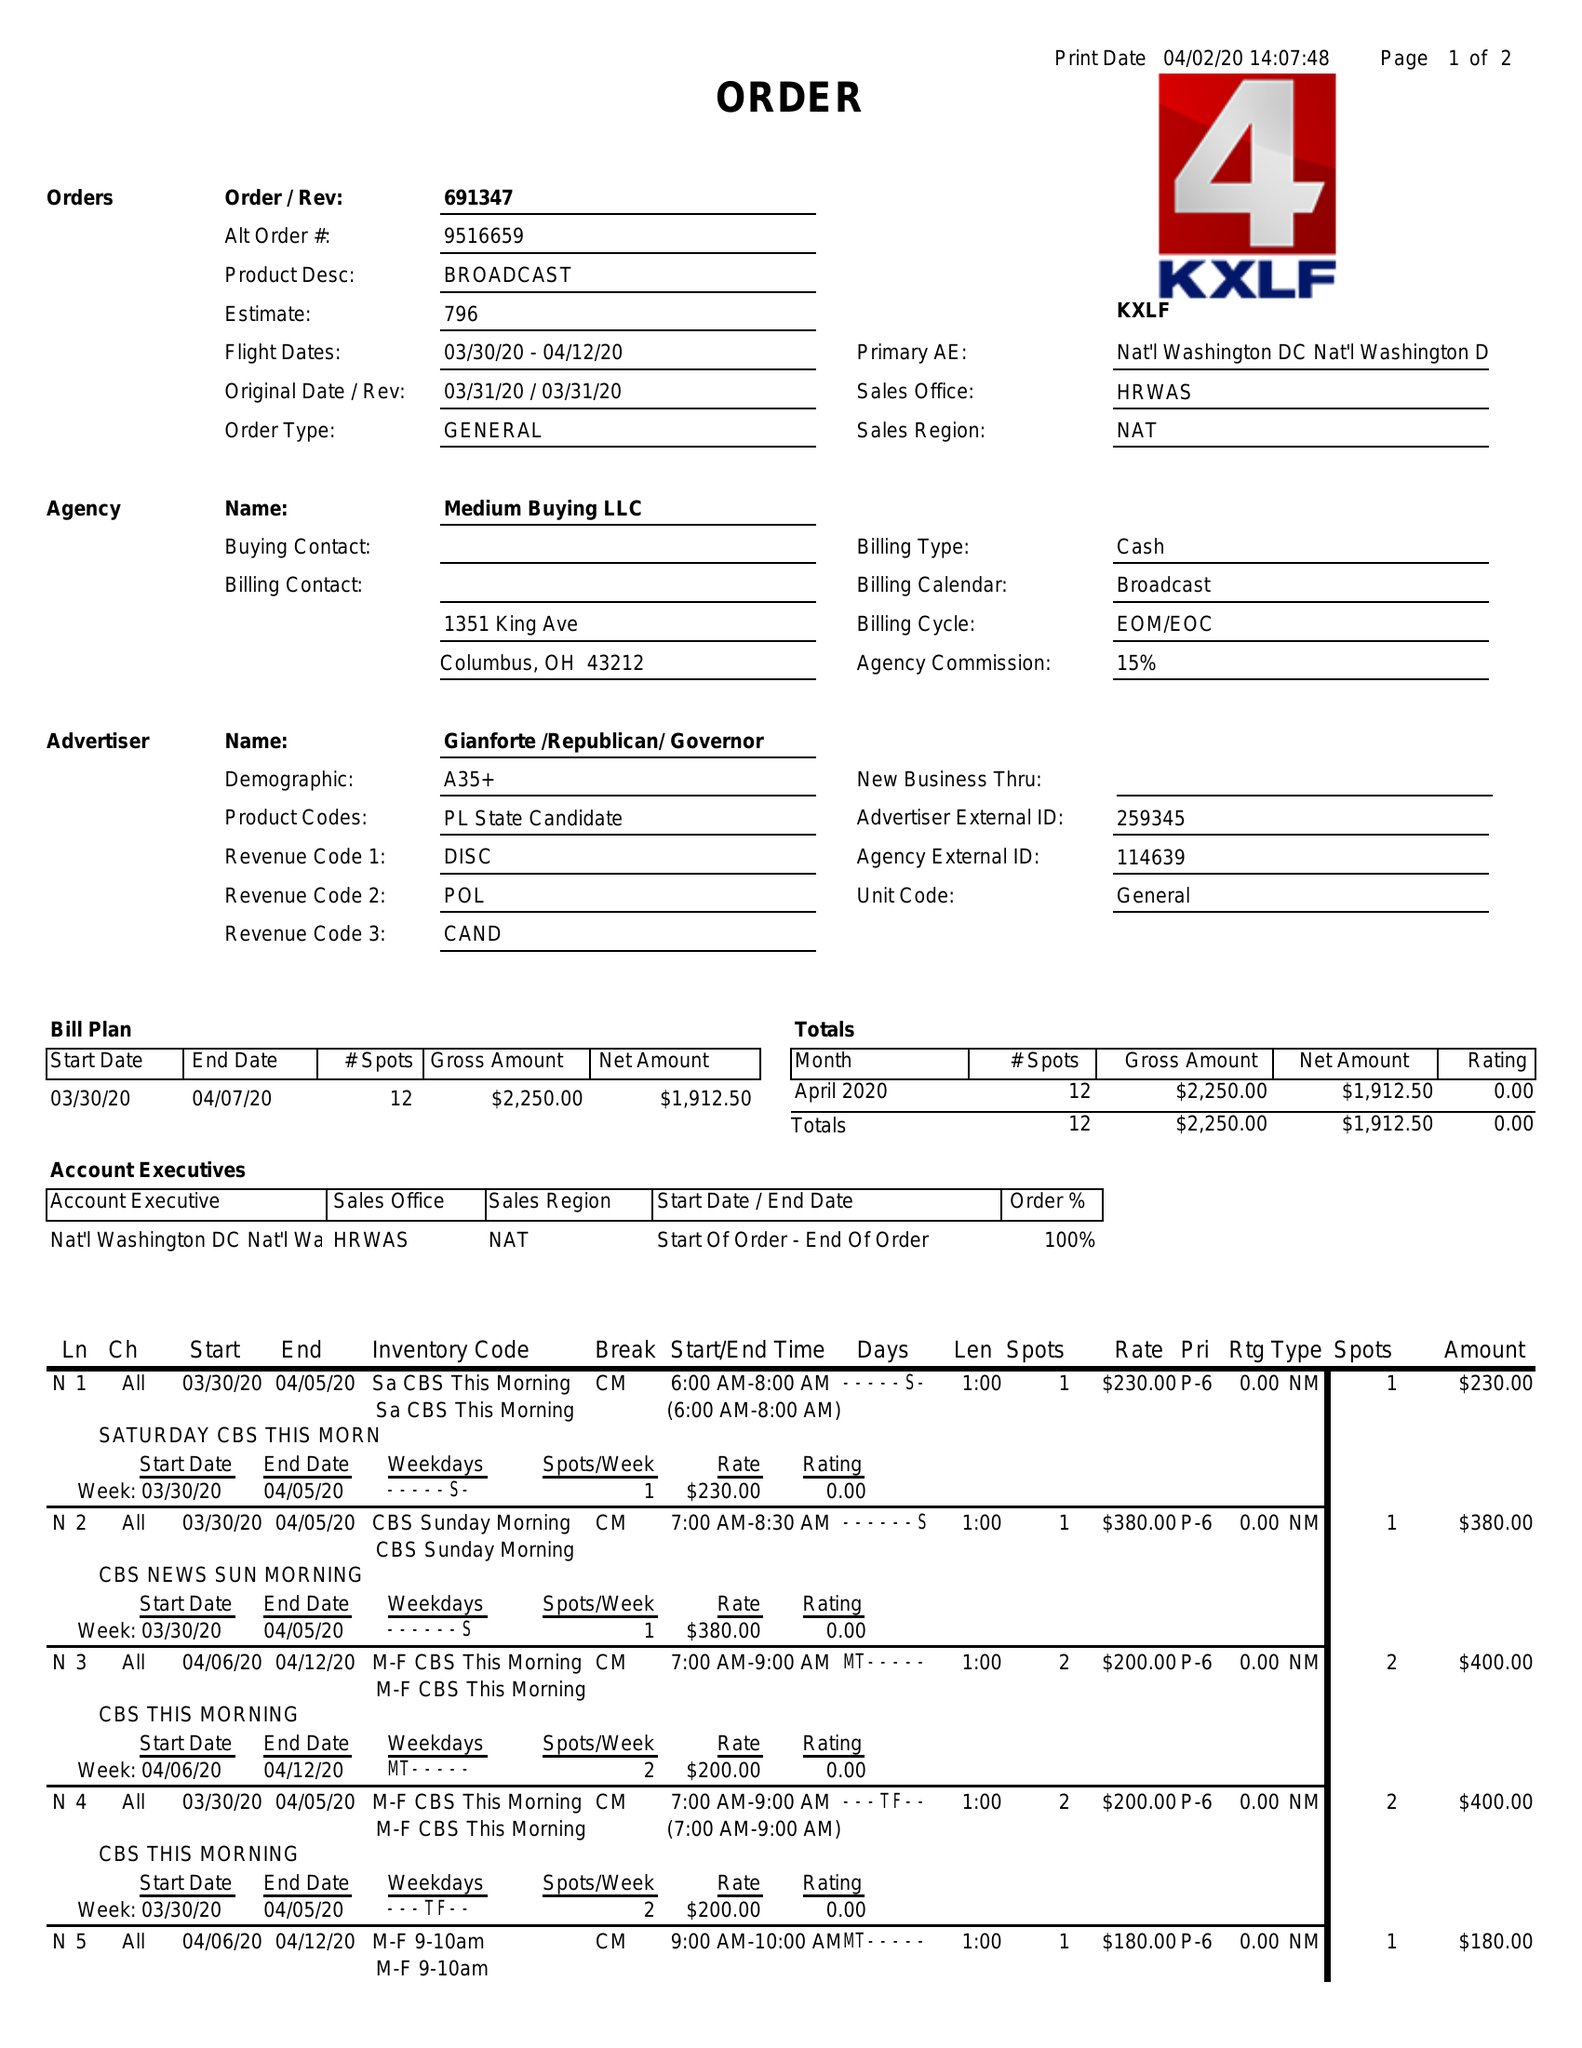What is the value for the contract_num?
Answer the question using a single word or phrase. 691347 